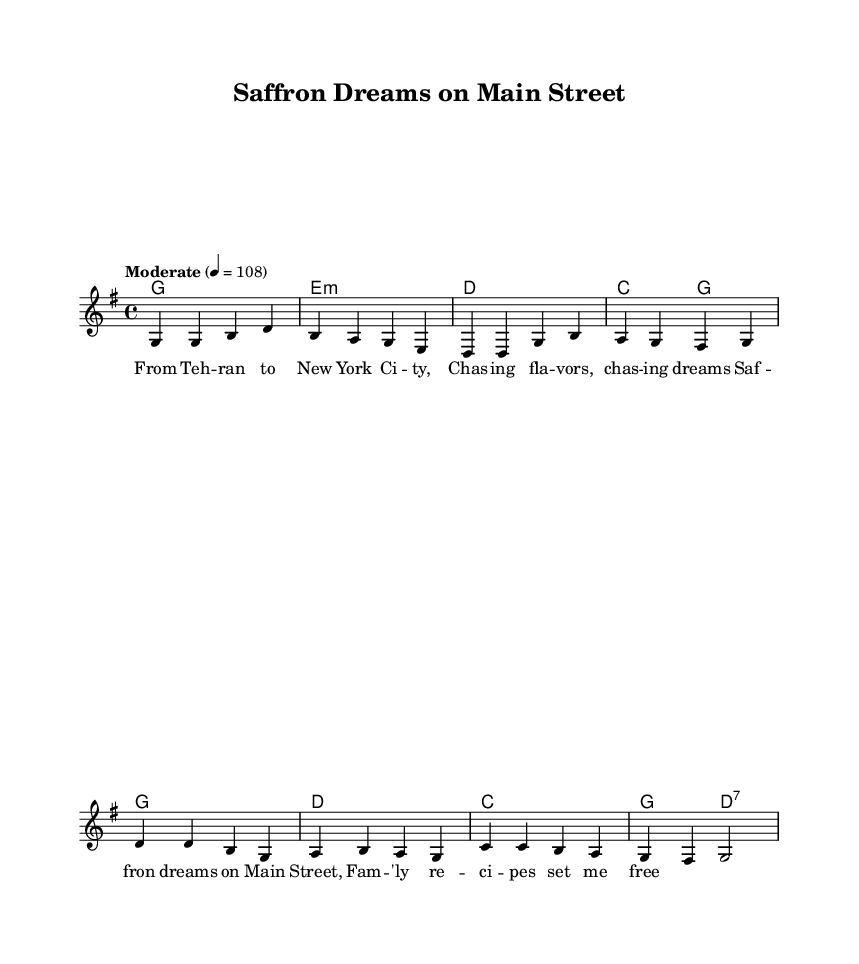What is the key signature of this music? The key signature is G major, which contains one sharp (F#). This can be identified by looking at the key signature at the beginning of the staff.
Answer: G major What is the time signature of this piece? The time signature is 4/4, which means there are four beats per measure and the quarter note receives one beat. This is indicated right after the clef and key signature.
Answer: 4/4 What is the tempo marking given in this sheet music? The tempo marking is "Moderate" with a metronome marking of 108 beats per minute. This information is provided above the staff and indicates the speed at which the piece should be played.
Answer: Moderate How many measures are there in the melody section? The melody section consists of 8 measures. This can be counted by looking at the bar lines, which separate the music into sections.
Answer: 8 measures What is the mood conveyed by the lyrics based on their words? The mood is nostalgic and hopeful. The lyrics speak to pursuing dreams and family connections, suggesting a warm and sentimental feeling, characteristic of many country songs.
Answer: Nostalgic What is the primary theme of the song indicated in the lyrics? The primary theme of the song centers around family and cultural heritage. The words highlight personal connections to family recipes and dreams, which are common themes in country music that celebrate roots and community.
Answer: Family and heritage What type of chords are used in the harmony section? The chords include major and minor chords, typical in country music, conveying a blend of emotions and adding depth to the piece. The presence of E minor suggests a reflective moment within the composition.
Answer: Major and minor chords 